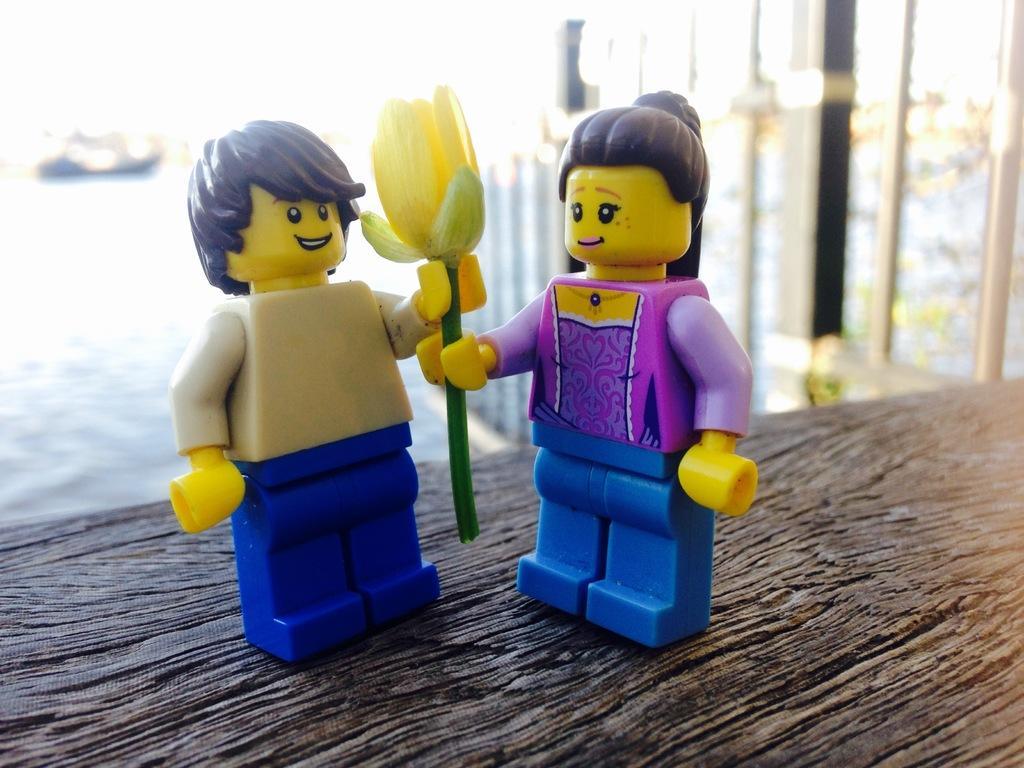Could you give a brief overview of what you see in this image? In this image we can see two toys holding a yellow flower on the table, some poles, some objects in the background and the background is blurred. 